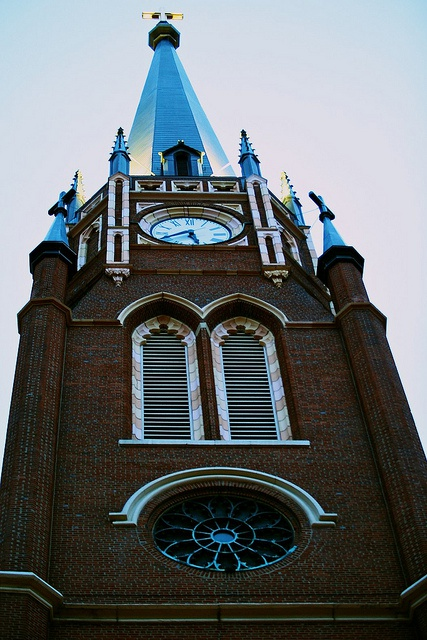Describe the objects in this image and their specific colors. I can see a clock in lightblue, black, and gray tones in this image. 